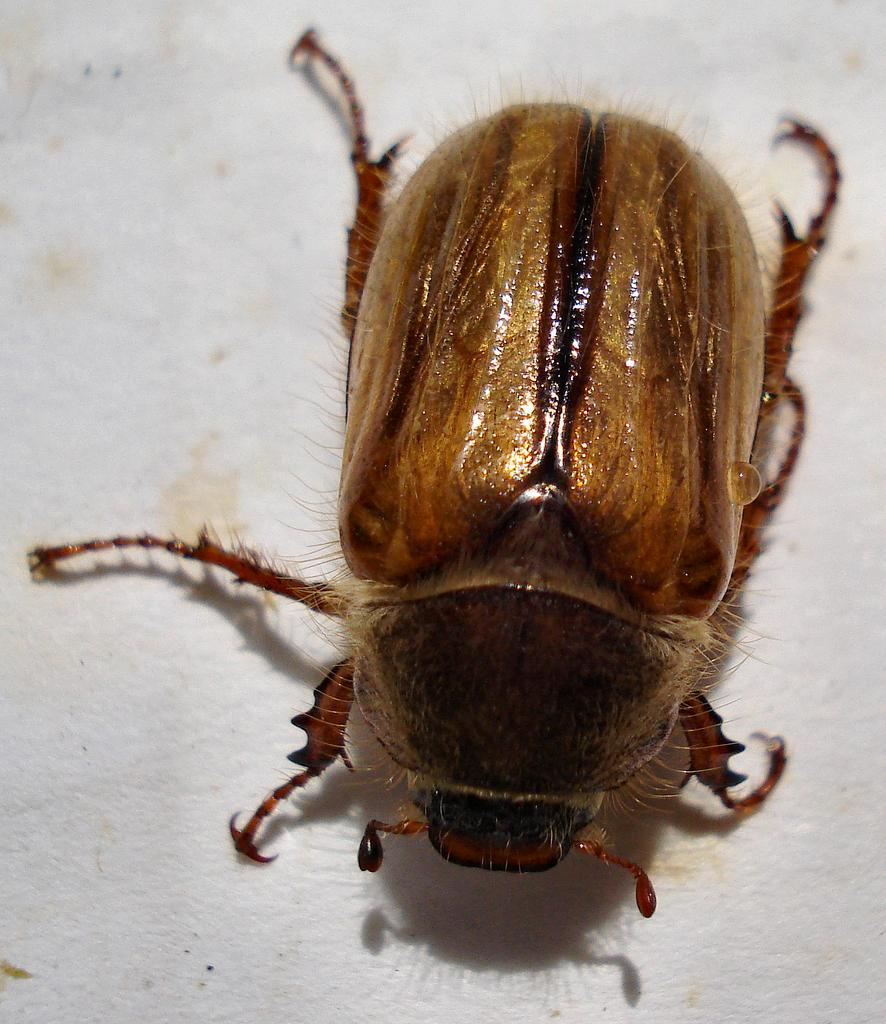What type of creature can be seen in the image? There is an insect in the image. What is the background or surface that the insect is on? The insect is on a white surface. What type of action is the insect performing in the image? The insect is not performing any specific action in the image; it is simply resting on the white surface. What type of wax can be seen in the image? There is no wax present in the image. 